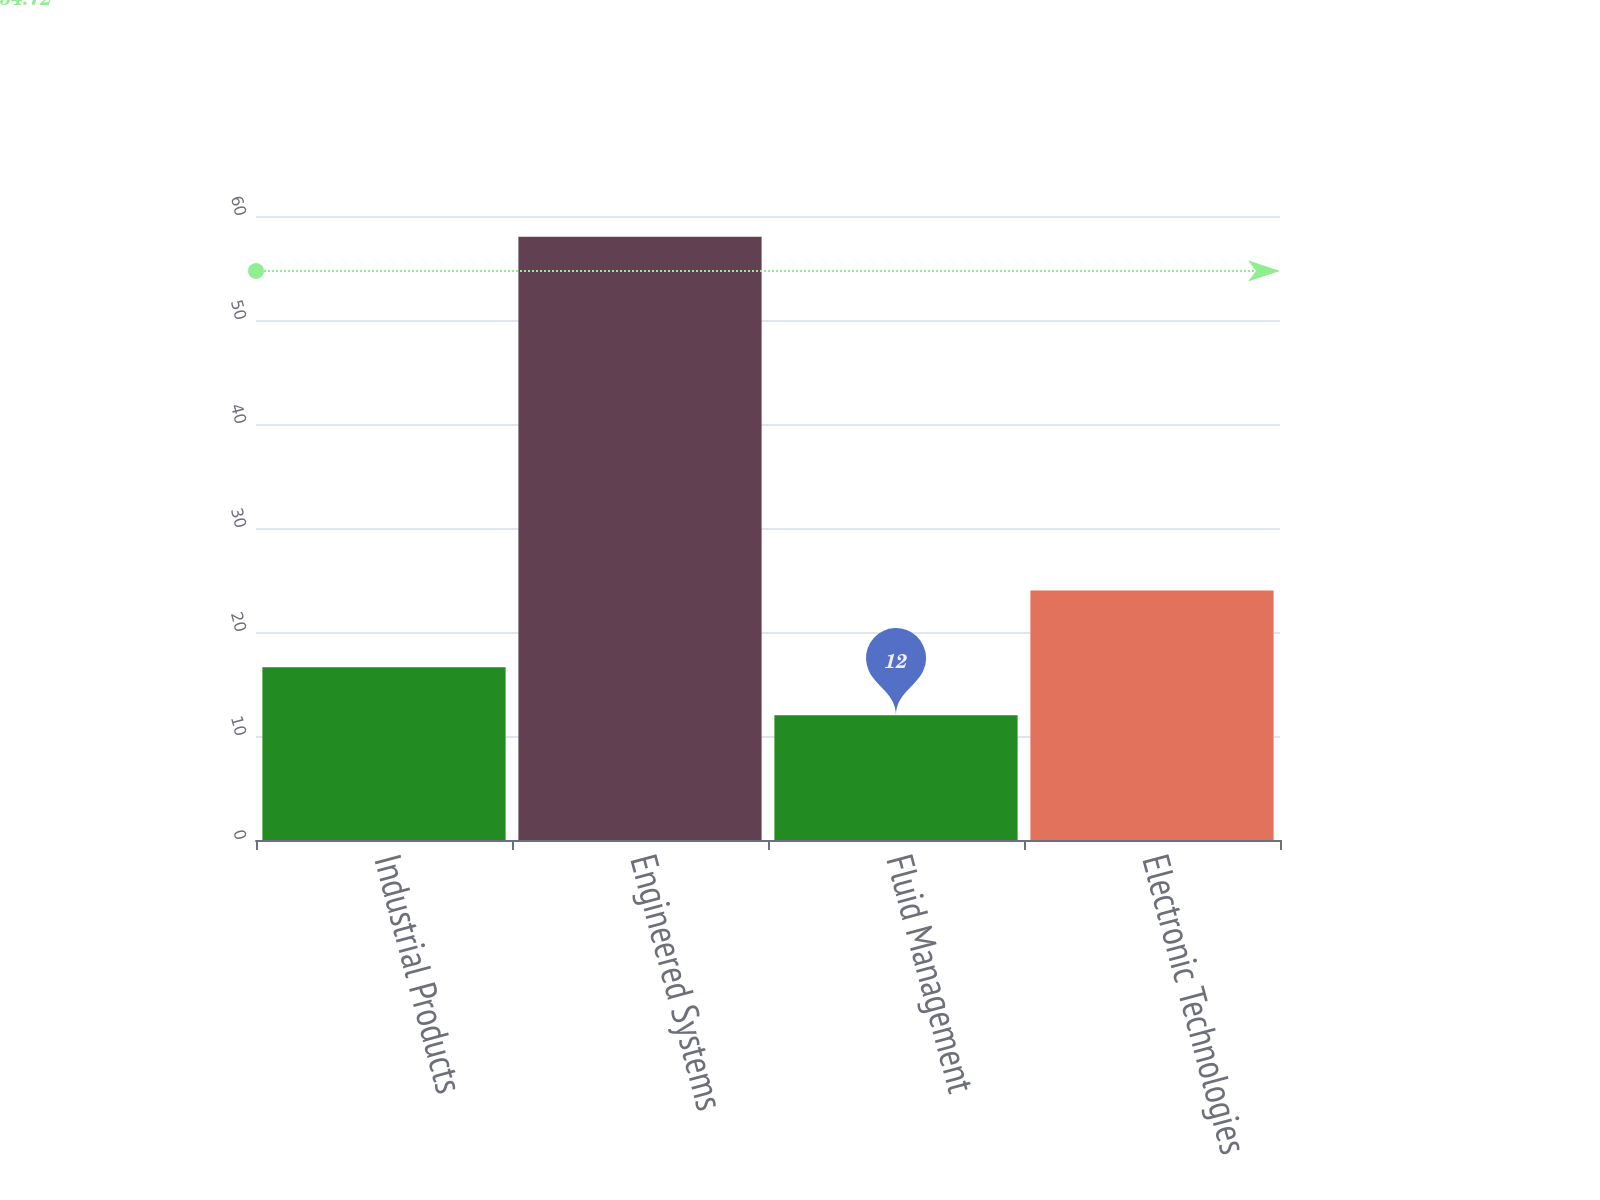<chart> <loc_0><loc_0><loc_500><loc_500><bar_chart><fcel>Industrial Products<fcel>Engineered Systems<fcel>Fluid Management<fcel>Electronic Technologies<nl><fcel>16.6<fcel>58<fcel>12<fcel>24<nl></chart> 